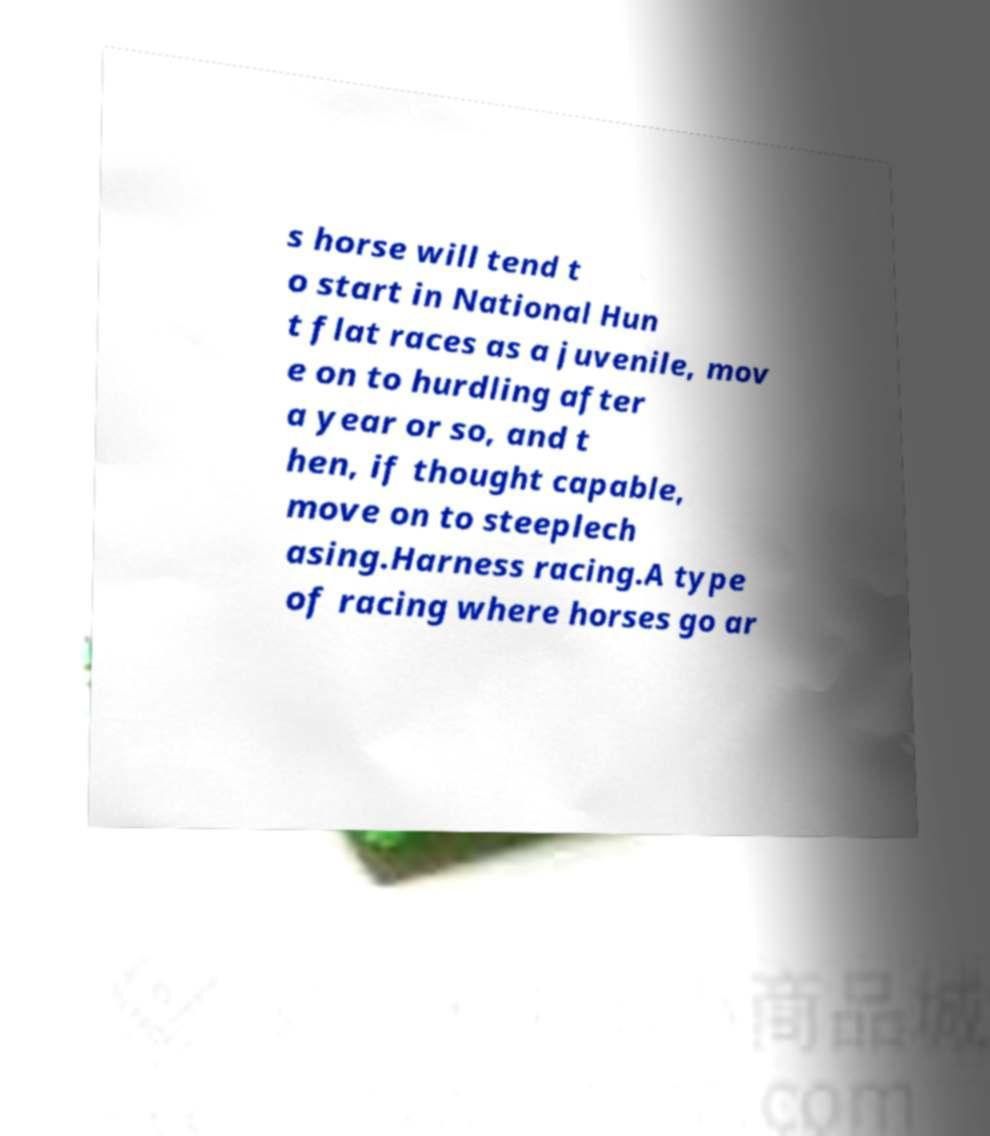There's text embedded in this image that I need extracted. Can you transcribe it verbatim? s horse will tend t o start in National Hun t flat races as a juvenile, mov e on to hurdling after a year or so, and t hen, if thought capable, move on to steeplech asing.Harness racing.A type of racing where horses go ar 